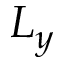Convert formula to latex. <formula><loc_0><loc_0><loc_500><loc_500>L _ { y }</formula> 